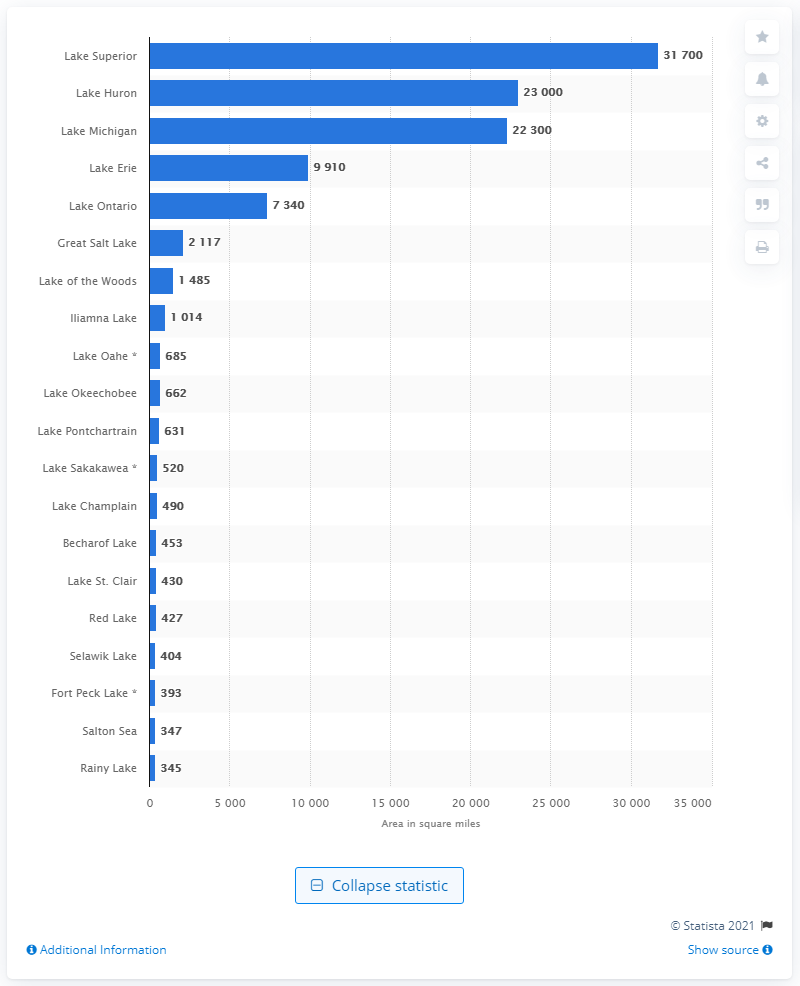Specify some key components in this picture. Lake Superior is the largest lake in the United States. 